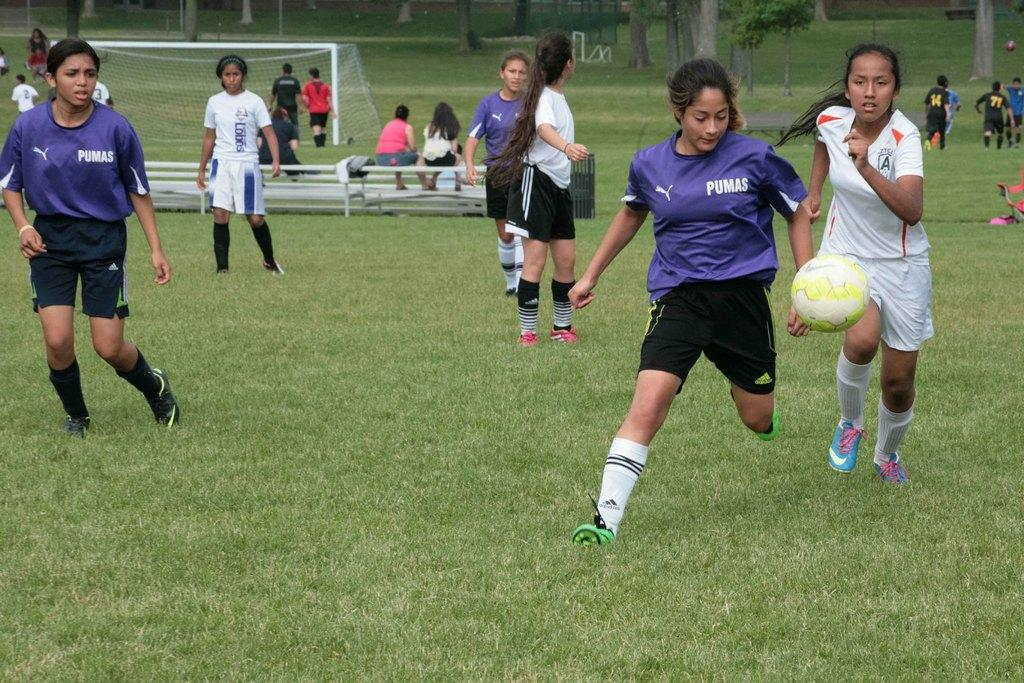<image>
Summarize the visual content of the image. A woman in a Pumas soccer jersey chases after the ball. 